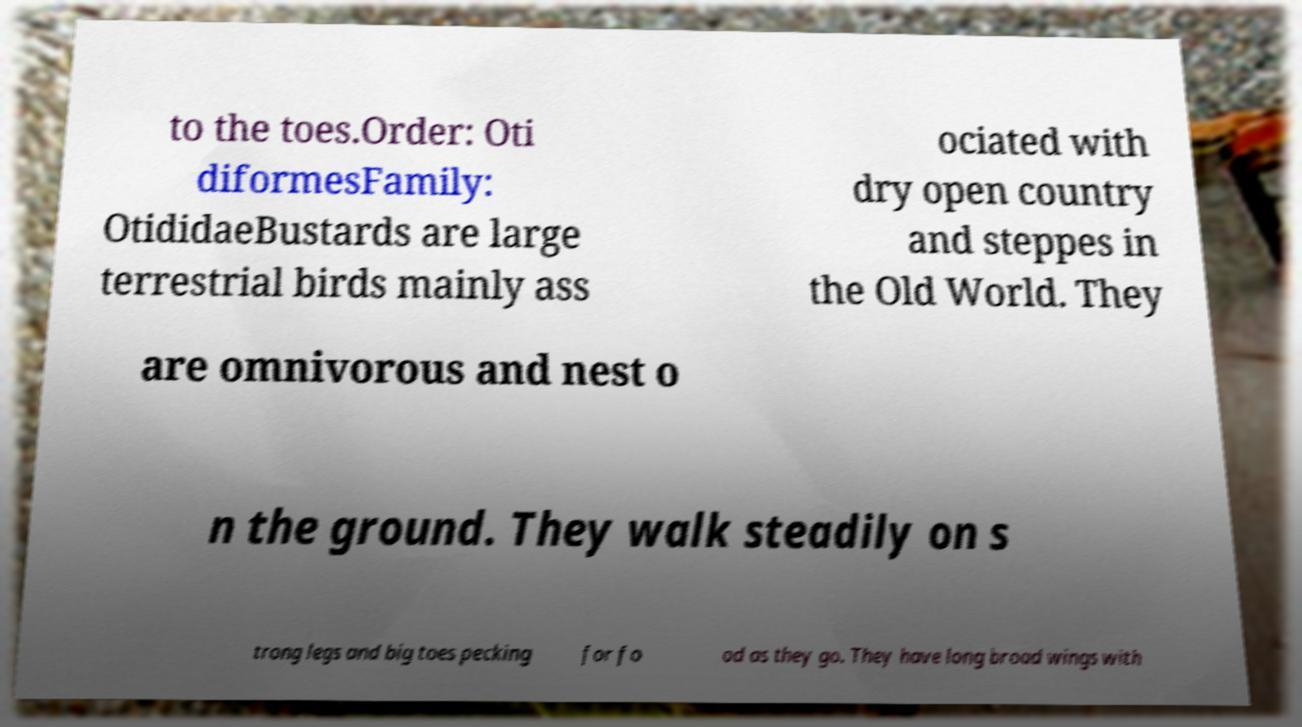Could you assist in decoding the text presented in this image and type it out clearly? to the toes.Order: Oti diformesFamily: OtididaeBustards are large terrestrial birds mainly ass ociated with dry open country and steppes in the Old World. They are omnivorous and nest o n the ground. They walk steadily on s trong legs and big toes pecking for fo od as they go. They have long broad wings with 